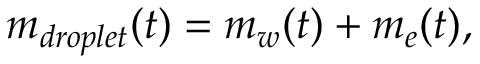<formula> <loc_0><loc_0><loc_500><loc_500>m _ { d r o p l e t } ( t ) = m _ { w } ( t ) + m _ { e } ( t ) ,</formula> 